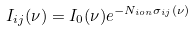<formula> <loc_0><loc_0><loc_500><loc_500>I _ { i j } ( \nu ) = I _ { 0 } ( \nu ) e ^ { - N _ { i o n } \sigma _ { i j } ( \nu ) }</formula> 